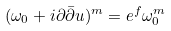Convert formula to latex. <formula><loc_0><loc_0><loc_500><loc_500>( \omega _ { 0 } + i \partial \bar { \partial } u ) ^ { m } = e ^ { f } \omega _ { 0 } ^ { m }</formula> 